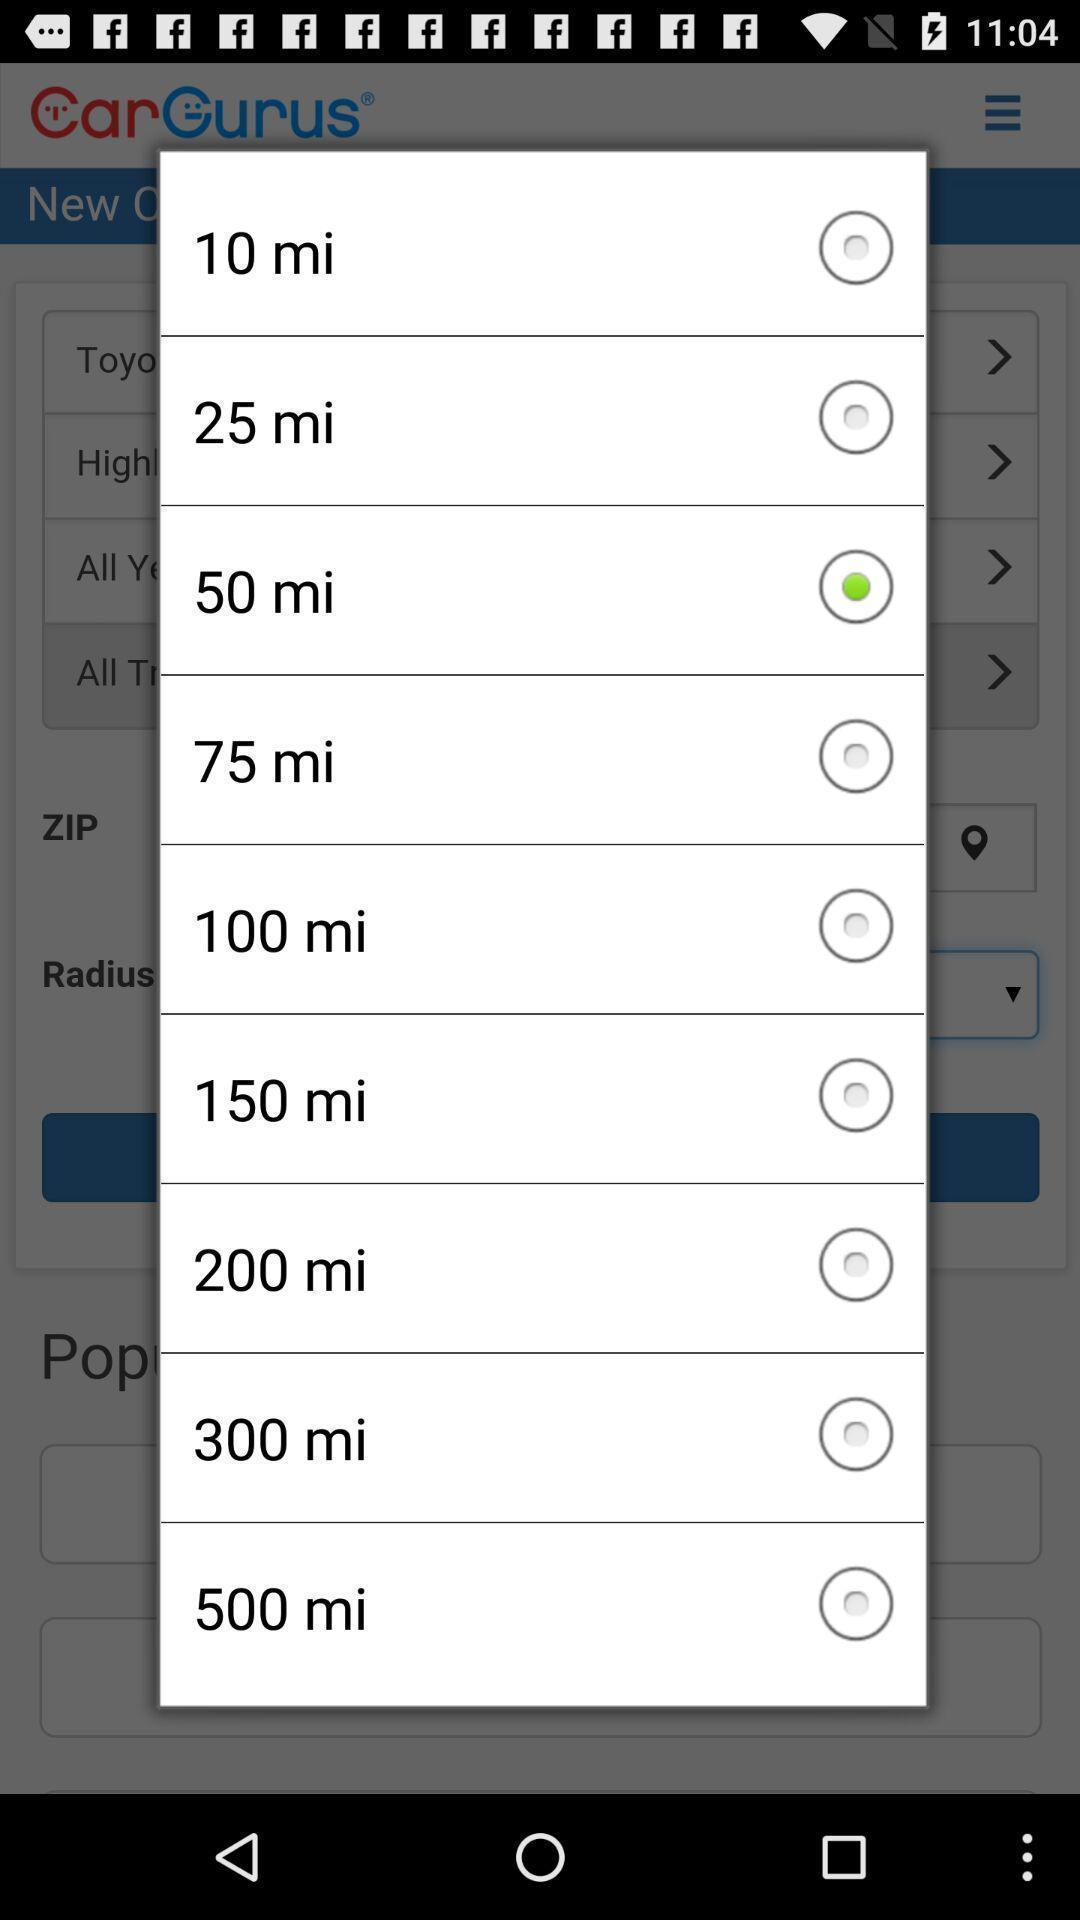Provide a textual representation of this image. Pop up showing various options. 